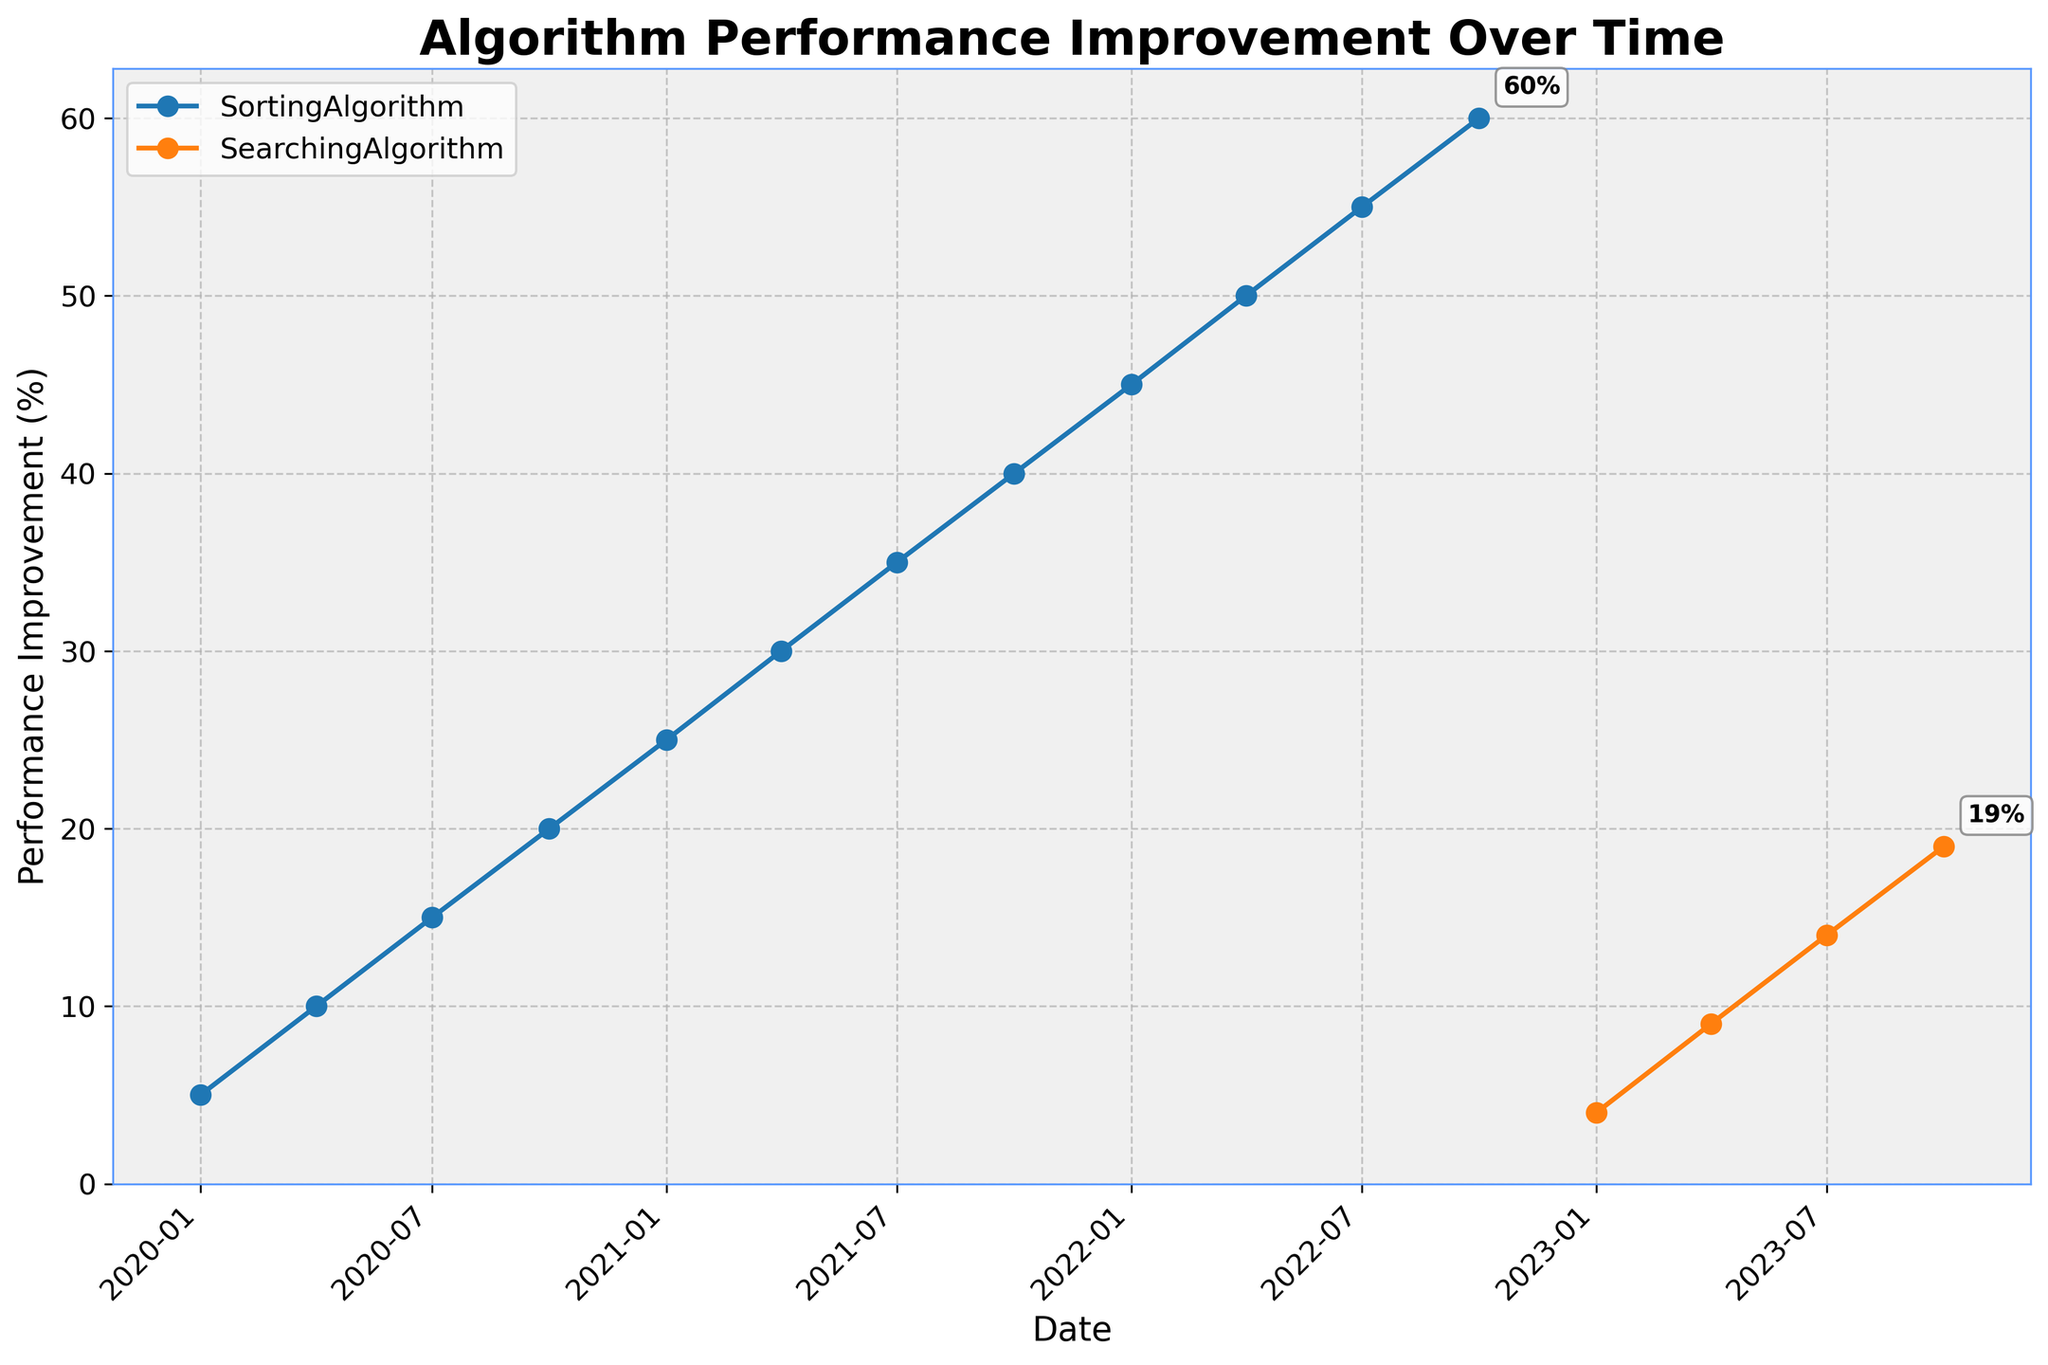What's the title of the figure? The title of a figure is typically located at the top of the chart and it explains what the figure is about. In this figure, the title is centered and in bold.
Answer: Algorithm Performance Improvement Over Time Which algorithms are represented in the figure? The algorithms represented can be identified from the legend in the top-left corner of the figure. These labels correspond to the lines plotted on the graph.
Answer: SortingAlgorithm, SearchingAlgorithm What is the performance improvement percentage of the SortingAlgorithm on 2020-04-01? To get this, find the SortingAlgorithm data series and locate the plotted point corresponding to the date 2020-04-01 on the x-axis. Then, trace it to the y-axis to get the value.
Answer: 10% How many data points are there for the SortingAlgorithm? Count the number of markers along the SortingAlgorithm line in the figure. Each marker represents one data point.
Answer: 12 By how much did the performance improvement percentage of the SearchingAlgorithm increase from 2023-01-01 to 2023-07-01? Find the performance improvement percentages for the SearchingAlgorithm at both specified dates and subtract the former from the latter: 14% - 4%.
Answer: 10% What is the range of performance improvement percentages for the SortingAlgorithm? The range is the difference between the maximum and minimum y-values of the SortingAlgorithm data series. The minimum is 5% and the maximum is 60%.
Answer: 55% Which algorithm has a higher performance improvement percentage on 2023-10-01? Compare the y-values of both algorithms at the date 2023-10-01. The SearchingAlgorithm value can be directly observed.
Answer: SearchingAlgorithm Which algorithm shows a more rapid improvement in performance over time? By observing the slopes of the lines, we see that the SortingAlgorithm has a steeper slope initially and then it becomes a straight line. The SearchingAlgorithm, starting in 2023, has a less steep slope comparatively.
Answer: SortingAlgorithm Between 2020-01-01 and 2021-01-01, by how much did the performance improvement of the SortingAlgorithm increase each quarter on average? There are four quarters in this period, and the performance improved from 5% to 25%, making an increase of 20%. Divide this by the number of quarters: 20% / 4
Answer: 5% per quarter 